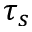Convert formula to latex. <formula><loc_0><loc_0><loc_500><loc_500>\tau _ { s }</formula> 